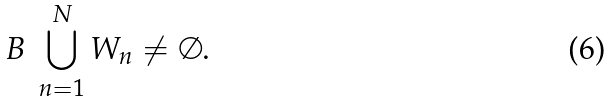<formula> <loc_0><loc_0><loc_500><loc_500>B \ \bigcup _ { n = 1 } ^ { N } W _ { n } \neq \emptyset .</formula> 